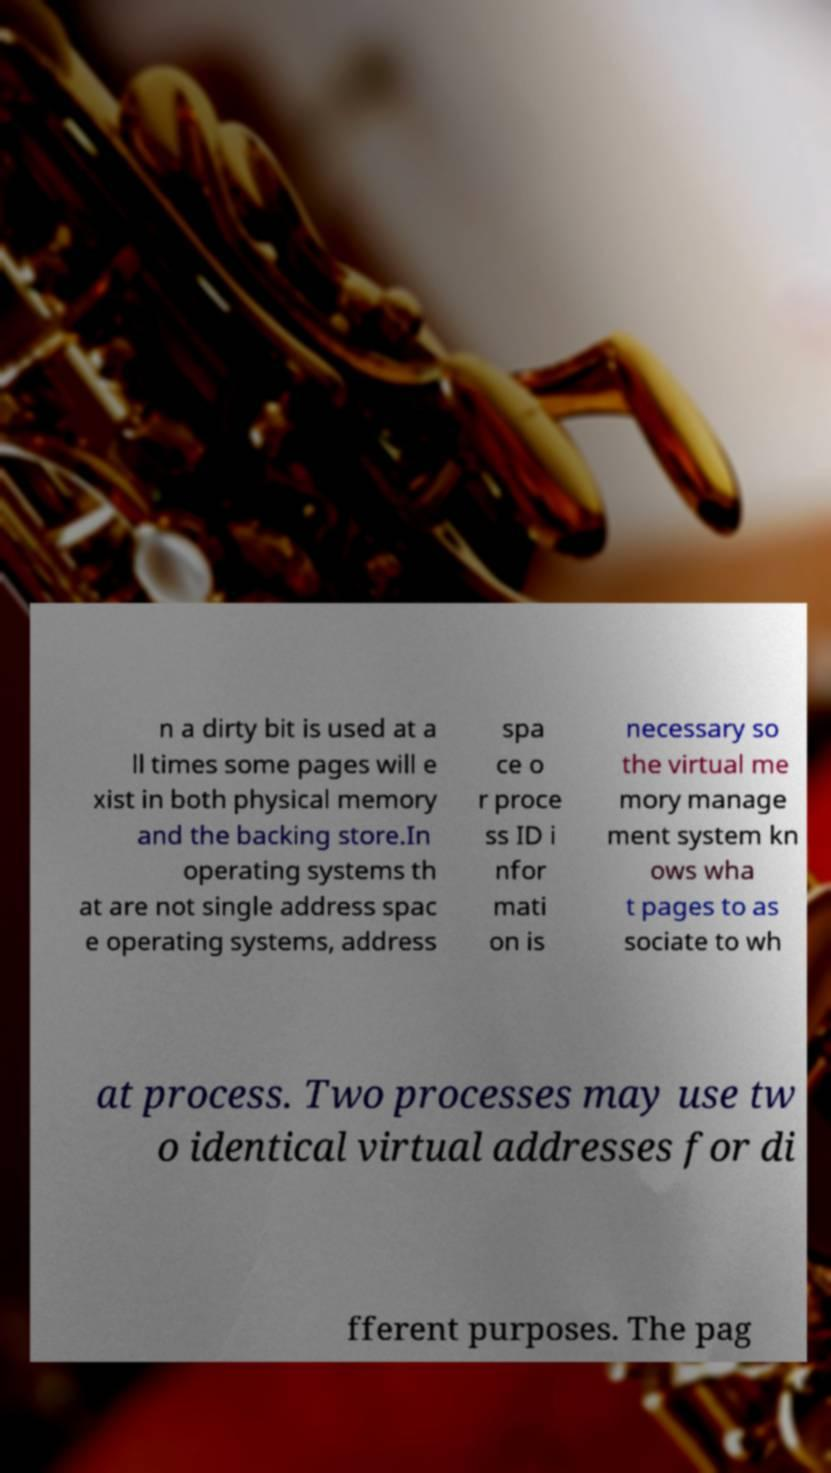Can you read and provide the text displayed in the image?This photo seems to have some interesting text. Can you extract and type it out for me? n a dirty bit is used at a ll times some pages will e xist in both physical memory and the backing store.In operating systems th at are not single address spac e operating systems, address spa ce o r proce ss ID i nfor mati on is necessary so the virtual me mory manage ment system kn ows wha t pages to as sociate to wh at process. Two processes may use tw o identical virtual addresses for di fferent purposes. The pag 